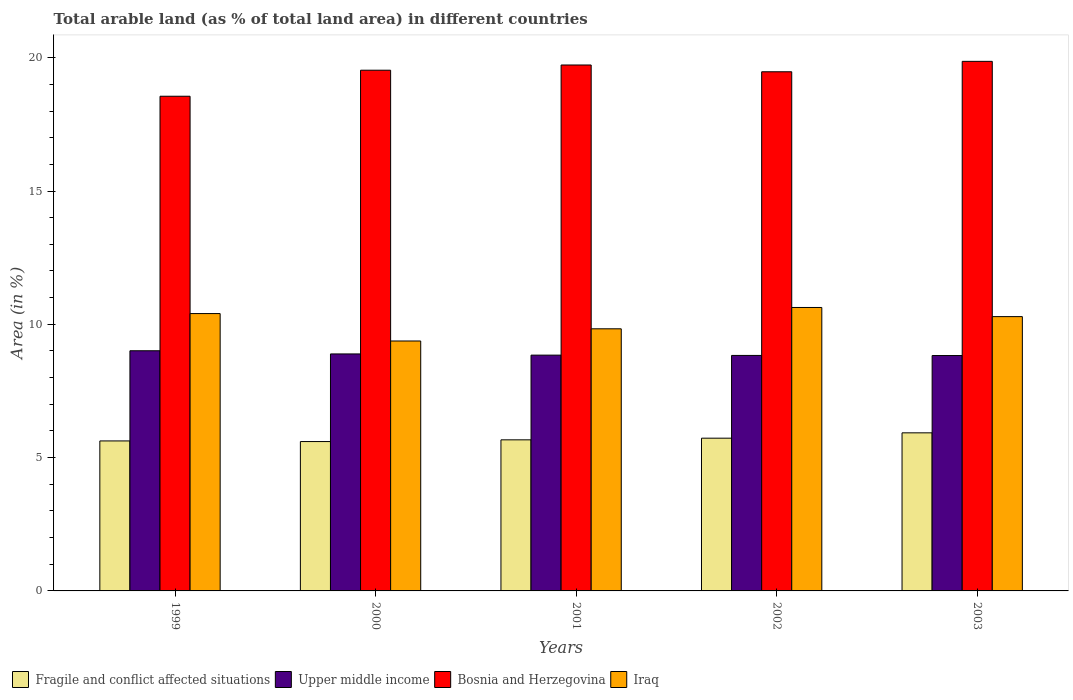In how many cases, is the number of bars for a given year not equal to the number of legend labels?
Your response must be concise. 0. What is the percentage of arable land in Upper middle income in 2002?
Provide a short and direct response. 8.83. Across all years, what is the maximum percentage of arable land in Bosnia and Herzegovina?
Your answer should be very brief. 19.86. Across all years, what is the minimum percentage of arable land in Bosnia and Herzegovina?
Keep it short and to the point. 18.55. What is the total percentage of arable land in Iraq in the graph?
Your answer should be very brief. 50.53. What is the difference between the percentage of arable land in Upper middle income in 2000 and that in 2001?
Offer a very short reply. 0.05. What is the difference between the percentage of arable land in Upper middle income in 2003 and the percentage of arable land in Iraq in 2001?
Your response must be concise. -1. What is the average percentage of arable land in Bosnia and Herzegovina per year?
Give a very brief answer. 19.43. In the year 2003, what is the difference between the percentage of arable land in Upper middle income and percentage of arable land in Bosnia and Herzegovina?
Your answer should be very brief. -11.03. What is the ratio of the percentage of arable land in Upper middle income in 2000 to that in 2002?
Provide a succinct answer. 1.01. Is the percentage of arable land in Iraq in 1999 less than that in 2002?
Your response must be concise. Yes. Is the difference between the percentage of arable land in Upper middle income in 2000 and 2001 greater than the difference between the percentage of arable land in Bosnia and Herzegovina in 2000 and 2001?
Provide a succinct answer. Yes. What is the difference between the highest and the second highest percentage of arable land in Iraq?
Provide a short and direct response. 0.23. What is the difference between the highest and the lowest percentage of arable land in Bosnia and Herzegovina?
Provide a succinct answer. 1.31. Is the sum of the percentage of arable land in Upper middle income in 1999 and 2001 greater than the maximum percentage of arable land in Bosnia and Herzegovina across all years?
Offer a terse response. No. What does the 4th bar from the left in 2003 represents?
Ensure brevity in your answer.  Iraq. What does the 4th bar from the right in 2001 represents?
Offer a terse response. Fragile and conflict affected situations. Is it the case that in every year, the sum of the percentage of arable land in Bosnia and Herzegovina and percentage of arable land in Iraq is greater than the percentage of arable land in Upper middle income?
Keep it short and to the point. Yes. How many bars are there?
Give a very brief answer. 20. How many years are there in the graph?
Your answer should be very brief. 5. Are the values on the major ticks of Y-axis written in scientific E-notation?
Offer a very short reply. No. Does the graph contain any zero values?
Make the answer very short. No. Does the graph contain grids?
Make the answer very short. No. Where does the legend appear in the graph?
Your answer should be very brief. Bottom left. How are the legend labels stacked?
Your response must be concise. Horizontal. What is the title of the graph?
Ensure brevity in your answer.  Total arable land (as % of total land area) in different countries. What is the label or title of the Y-axis?
Provide a short and direct response. Area (in %). What is the Area (in %) in Fragile and conflict affected situations in 1999?
Keep it short and to the point. 5.63. What is the Area (in %) in Upper middle income in 1999?
Give a very brief answer. 9.01. What is the Area (in %) of Bosnia and Herzegovina in 1999?
Keep it short and to the point. 18.55. What is the Area (in %) in Iraq in 1999?
Provide a succinct answer. 10.4. What is the Area (in %) of Fragile and conflict affected situations in 2000?
Provide a short and direct response. 5.6. What is the Area (in %) in Upper middle income in 2000?
Offer a terse response. 8.89. What is the Area (in %) of Bosnia and Herzegovina in 2000?
Provide a succinct answer. 19.53. What is the Area (in %) of Iraq in 2000?
Keep it short and to the point. 9.37. What is the Area (in %) in Fragile and conflict affected situations in 2001?
Your response must be concise. 5.67. What is the Area (in %) of Upper middle income in 2001?
Offer a very short reply. 8.84. What is the Area (in %) of Bosnia and Herzegovina in 2001?
Your response must be concise. 19.73. What is the Area (in %) of Iraq in 2001?
Provide a short and direct response. 9.83. What is the Area (in %) of Fragile and conflict affected situations in 2002?
Offer a terse response. 5.73. What is the Area (in %) of Upper middle income in 2002?
Make the answer very short. 8.83. What is the Area (in %) of Bosnia and Herzegovina in 2002?
Provide a short and direct response. 19.47. What is the Area (in %) of Iraq in 2002?
Keep it short and to the point. 10.63. What is the Area (in %) of Fragile and conflict affected situations in 2003?
Provide a short and direct response. 5.93. What is the Area (in %) in Upper middle income in 2003?
Keep it short and to the point. 8.83. What is the Area (in %) in Bosnia and Herzegovina in 2003?
Keep it short and to the point. 19.86. What is the Area (in %) in Iraq in 2003?
Provide a short and direct response. 10.29. Across all years, what is the maximum Area (in %) of Fragile and conflict affected situations?
Your answer should be very brief. 5.93. Across all years, what is the maximum Area (in %) in Upper middle income?
Ensure brevity in your answer.  9.01. Across all years, what is the maximum Area (in %) in Bosnia and Herzegovina?
Your answer should be very brief. 19.86. Across all years, what is the maximum Area (in %) of Iraq?
Your answer should be compact. 10.63. Across all years, what is the minimum Area (in %) of Fragile and conflict affected situations?
Provide a succinct answer. 5.6. Across all years, what is the minimum Area (in %) of Upper middle income?
Offer a very short reply. 8.83. Across all years, what is the minimum Area (in %) of Bosnia and Herzegovina?
Give a very brief answer. 18.55. Across all years, what is the minimum Area (in %) in Iraq?
Keep it short and to the point. 9.37. What is the total Area (in %) of Fragile and conflict affected situations in the graph?
Keep it short and to the point. 28.55. What is the total Area (in %) of Upper middle income in the graph?
Give a very brief answer. 44.4. What is the total Area (in %) in Bosnia and Herzegovina in the graph?
Offer a terse response. 97.15. What is the total Area (in %) in Iraq in the graph?
Your response must be concise. 50.53. What is the difference between the Area (in %) of Fragile and conflict affected situations in 1999 and that in 2000?
Your answer should be compact. 0.02. What is the difference between the Area (in %) in Upper middle income in 1999 and that in 2000?
Make the answer very short. 0.12. What is the difference between the Area (in %) in Bosnia and Herzegovina in 1999 and that in 2000?
Your answer should be compact. -0.98. What is the difference between the Area (in %) in Iraq in 1999 and that in 2000?
Provide a short and direct response. 1.03. What is the difference between the Area (in %) in Fragile and conflict affected situations in 1999 and that in 2001?
Your response must be concise. -0.04. What is the difference between the Area (in %) of Upper middle income in 1999 and that in 2001?
Keep it short and to the point. 0.16. What is the difference between the Area (in %) of Bosnia and Herzegovina in 1999 and that in 2001?
Make the answer very short. -1.17. What is the difference between the Area (in %) in Iraq in 1999 and that in 2001?
Provide a succinct answer. 0.57. What is the difference between the Area (in %) of Fragile and conflict affected situations in 1999 and that in 2002?
Your response must be concise. -0.1. What is the difference between the Area (in %) in Upper middle income in 1999 and that in 2002?
Offer a very short reply. 0.18. What is the difference between the Area (in %) in Bosnia and Herzegovina in 1999 and that in 2002?
Give a very brief answer. -0.92. What is the difference between the Area (in %) of Iraq in 1999 and that in 2002?
Offer a very short reply. -0.23. What is the difference between the Area (in %) of Fragile and conflict affected situations in 1999 and that in 2003?
Offer a very short reply. -0.3. What is the difference between the Area (in %) of Upper middle income in 1999 and that in 2003?
Provide a succinct answer. 0.18. What is the difference between the Area (in %) in Bosnia and Herzegovina in 1999 and that in 2003?
Provide a short and direct response. -1.31. What is the difference between the Area (in %) in Iraq in 1999 and that in 2003?
Your answer should be very brief. 0.11. What is the difference between the Area (in %) of Fragile and conflict affected situations in 2000 and that in 2001?
Your response must be concise. -0.06. What is the difference between the Area (in %) of Upper middle income in 2000 and that in 2001?
Ensure brevity in your answer.  0.04. What is the difference between the Area (in %) of Bosnia and Herzegovina in 2000 and that in 2001?
Give a very brief answer. -0.2. What is the difference between the Area (in %) in Iraq in 2000 and that in 2001?
Your answer should be compact. -0.46. What is the difference between the Area (in %) of Fragile and conflict affected situations in 2000 and that in 2002?
Ensure brevity in your answer.  -0.13. What is the difference between the Area (in %) in Upper middle income in 2000 and that in 2002?
Offer a terse response. 0.06. What is the difference between the Area (in %) in Bosnia and Herzegovina in 2000 and that in 2002?
Your answer should be compact. 0.06. What is the difference between the Area (in %) of Iraq in 2000 and that in 2002?
Offer a terse response. -1.26. What is the difference between the Area (in %) in Fragile and conflict affected situations in 2000 and that in 2003?
Make the answer very short. -0.33. What is the difference between the Area (in %) of Bosnia and Herzegovina in 2000 and that in 2003?
Your answer should be compact. -0.33. What is the difference between the Area (in %) in Iraq in 2000 and that in 2003?
Keep it short and to the point. -0.91. What is the difference between the Area (in %) in Fragile and conflict affected situations in 2001 and that in 2002?
Your response must be concise. -0.06. What is the difference between the Area (in %) of Upper middle income in 2001 and that in 2002?
Your answer should be very brief. 0.01. What is the difference between the Area (in %) in Bosnia and Herzegovina in 2001 and that in 2002?
Make the answer very short. 0.25. What is the difference between the Area (in %) in Iraq in 2001 and that in 2002?
Provide a short and direct response. -0.8. What is the difference between the Area (in %) in Fragile and conflict affected situations in 2001 and that in 2003?
Offer a very short reply. -0.26. What is the difference between the Area (in %) in Upper middle income in 2001 and that in 2003?
Offer a terse response. 0.01. What is the difference between the Area (in %) in Bosnia and Herzegovina in 2001 and that in 2003?
Provide a short and direct response. -0.14. What is the difference between the Area (in %) of Iraq in 2001 and that in 2003?
Provide a short and direct response. -0.46. What is the difference between the Area (in %) of Fragile and conflict affected situations in 2002 and that in 2003?
Offer a terse response. -0.2. What is the difference between the Area (in %) of Upper middle income in 2002 and that in 2003?
Provide a short and direct response. 0. What is the difference between the Area (in %) in Bosnia and Herzegovina in 2002 and that in 2003?
Ensure brevity in your answer.  -0.39. What is the difference between the Area (in %) of Iraq in 2002 and that in 2003?
Your answer should be very brief. 0.34. What is the difference between the Area (in %) of Fragile and conflict affected situations in 1999 and the Area (in %) of Upper middle income in 2000?
Offer a terse response. -3.26. What is the difference between the Area (in %) in Fragile and conflict affected situations in 1999 and the Area (in %) in Bosnia and Herzegovina in 2000?
Provide a succinct answer. -13.91. What is the difference between the Area (in %) of Fragile and conflict affected situations in 1999 and the Area (in %) of Iraq in 2000?
Make the answer very short. -3.75. What is the difference between the Area (in %) in Upper middle income in 1999 and the Area (in %) in Bosnia and Herzegovina in 2000?
Give a very brief answer. -10.52. What is the difference between the Area (in %) in Upper middle income in 1999 and the Area (in %) in Iraq in 2000?
Offer a very short reply. -0.37. What is the difference between the Area (in %) of Bosnia and Herzegovina in 1999 and the Area (in %) of Iraq in 2000?
Your answer should be very brief. 9.18. What is the difference between the Area (in %) of Fragile and conflict affected situations in 1999 and the Area (in %) of Upper middle income in 2001?
Your answer should be compact. -3.22. What is the difference between the Area (in %) of Fragile and conflict affected situations in 1999 and the Area (in %) of Bosnia and Herzegovina in 2001?
Your response must be concise. -14.1. What is the difference between the Area (in %) of Fragile and conflict affected situations in 1999 and the Area (in %) of Iraq in 2001?
Provide a succinct answer. -4.21. What is the difference between the Area (in %) of Upper middle income in 1999 and the Area (in %) of Bosnia and Herzegovina in 2001?
Ensure brevity in your answer.  -10.72. What is the difference between the Area (in %) in Upper middle income in 1999 and the Area (in %) in Iraq in 2001?
Make the answer very short. -0.82. What is the difference between the Area (in %) of Bosnia and Herzegovina in 1999 and the Area (in %) of Iraq in 2001?
Your answer should be very brief. 8.72. What is the difference between the Area (in %) in Fragile and conflict affected situations in 1999 and the Area (in %) in Upper middle income in 2002?
Give a very brief answer. -3.21. What is the difference between the Area (in %) in Fragile and conflict affected situations in 1999 and the Area (in %) in Bosnia and Herzegovina in 2002?
Keep it short and to the point. -13.85. What is the difference between the Area (in %) in Fragile and conflict affected situations in 1999 and the Area (in %) in Iraq in 2002?
Offer a very short reply. -5.01. What is the difference between the Area (in %) in Upper middle income in 1999 and the Area (in %) in Bosnia and Herzegovina in 2002?
Provide a short and direct response. -10.46. What is the difference between the Area (in %) in Upper middle income in 1999 and the Area (in %) in Iraq in 2002?
Your answer should be very brief. -1.62. What is the difference between the Area (in %) of Bosnia and Herzegovina in 1999 and the Area (in %) of Iraq in 2002?
Make the answer very short. 7.92. What is the difference between the Area (in %) of Fragile and conflict affected situations in 1999 and the Area (in %) of Upper middle income in 2003?
Ensure brevity in your answer.  -3.2. What is the difference between the Area (in %) of Fragile and conflict affected situations in 1999 and the Area (in %) of Bosnia and Herzegovina in 2003?
Provide a succinct answer. -14.24. What is the difference between the Area (in %) in Fragile and conflict affected situations in 1999 and the Area (in %) in Iraq in 2003?
Make the answer very short. -4.66. What is the difference between the Area (in %) of Upper middle income in 1999 and the Area (in %) of Bosnia and Herzegovina in 2003?
Your answer should be very brief. -10.85. What is the difference between the Area (in %) in Upper middle income in 1999 and the Area (in %) in Iraq in 2003?
Your answer should be compact. -1.28. What is the difference between the Area (in %) in Bosnia and Herzegovina in 1999 and the Area (in %) in Iraq in 2003?
Your answer should be very brief. 8.27. What is the difference between the Area (in %) in Fragile and conflict affected situations in 2000 and the Area (in %) in Upper middle income in 2001?
Your answer should be very brief. -3.24. What is the difference between the Area (in %) of Fragile and conflict affected situations in 2000 and the Area (in %) of Bosnia and Herzegovina in 2001?
Your answer should be compact. -14.12. What is the difference between the Area (in %) in Fragile and conflict affected situations in 2000 and the Area (in %) in Iraq in 2001?
Give a very brief answer. -4.23. What is the difference between the Area (in %) in Upper middle income in 2000 and the Area (in %) in Bosnia and Herzegovina in 2001?
Provide a short and direct response. -10.84. What is the difference between the Area (in %) in Upper middle income in 2000 and the Area (in %) in Iraq in 2001?
Keep it short and to the point. -0.94. What is the difference between the Area (in %) of Bosnia and Herzegovina in 2000 and the Area (in %) of Iraq in 2001?
Your answer should be compact. 9.7. What is the difference between the Area (in %) in Fragile and conflict affected situations in 2000 and the Area (in %) in Upper middle income in 2002?
Ensure brevity in your answer.  -3.23. What is the difference between the Area (in %) of Fragile and conflict affected situations in 2000 and the Area (in %) of Bosnia and Herzegovina in 2002?
Your answer should be very brief. -13.87. What is the difference between the Area (in %) in Fragile and conflict affected situations in 2000 and the Area (in %) in Iraq in 2002?
Give a very brief answer. -5.03. What is the difference between the Area (in %) of Upper middle income in 2000 and the Area (in %) of Bosnia and Herzegovina in 2002?
Keep it short and to the point. -10.58. What is the difference between the Area (in %) of Upper middle income in 2000 and the Area (in %) of Iraq in 2002?
Offer a very short reply. -1.74. What is the difference between the Area (in %) of Bosnia and Herzegovina in 2000 and the Area (in %) of Iraq in 2002?
Provide a short and direct response. 8.9. What is the difference between the Area (in %) in Fragile and conflict affected situations in 2000 and the Area (in %) in Upper middle income in 2003?
Your answer should be compact. -3.23. What is the difference between the Area (in %) of Fragile and conflict affected situations in 2000 and the Area (in %) of Bosnia and Herzegovina in 2003?
Offer a very short reply. -14.26. What is the difference between the Area (in %) in Fragile and conflict affected situations in 2000 and the Area (in %) in Iraq in 2003?
Your response must be concise. -4.69. What is the difference between the Area (in %) of Upper middle income in 2000 and the Area (in %) of Bosnia and Herzegovina in 2003?
Make the answer very short. -10.97. What is the difference between the Area (in %) in Upper middle income in 2000 and the Area (in %) in Iraq in 2003?
Offer a terse response. -1.4. What is the difference between the Area (in %) of Bosnia and Herzegovina in 2000 and the Area (in %) of Iraq in 2003?
Offer a terse response. 9.24. What is the difference between the Area (in %) of Fragile and conflict affected situations in 2001 and the Area (in %) of Upper middle income in 2002?
Give a very brief answer. -3.17. What is the difference between the Area (in %) of Fragile and conflict affected situations in 2001 and the Area (in %) of Bosnia and Herzegovina in 2002?
Give a very brief answer. -13.81. What is the difference between the Area (in %) in Fragile and conflict affected situations in 2001 and the Area (in %) in Iraq in 2002?
Give a very brief answer. -4.96. What is the difference between the Area (in %) of Upper middle income in 2001 and the Area (in %) of Bosnia and Herzegovina in 2002?
Your answer should be very brief. -10.63. What is the difference between the Area (in %) of Upper middle income in 2001 and the Area (in %) of Iraq in 2002?
Give a very brief answer. -1.79. What is the difference between the Area (in %) in Bosnia and Herzegovina in 2001 and the Area (in %) in Iraq in 2002?
Make the answer very short. 9.09. What is the difference between the Area (in %) of Fragile and conflict affected situations in 2001 and the Area (in %) of Upper middle income in 2003?
Provide a short and direct response. -3.16. What is the difference between the Area (in %) in Fragile and conflict affected situations in 2001 and the Area (in %) in Bosnia and Herzegovina in 2003?
Offer a terse response. -14.2. What is the difference between the Area (in %) of Fragile and conflict affected situations in 2001 and the Area (in %) of Iraq in 2003?
Give a very brief answer. -4.62. What is the difference between the Area (in %) in Upper middle income in 2001 and the Area (in %) in Bosnia and Herzegovina in 2003?
Provide a succinct answer. -11.02. What is the difference between the Area (in %) in Upper middle income in 2001 and the Area (in %) in Iraq in 2003?
Provide a succinct answer. -1.44. What is the difference between the Area (in %) of Bosnia and Herzegovina in 2001 and the Area (in %) of Iraq in 2003?
Your answer should be compact. 9.44. What is the difference between the Area (in %) in Fragile and conflict affected situations in 2002 and the Area (in %) in Upper middle income in 2003?
Ensure brevity in your answer.  -3.1. What is the difference between the Area (in %) in Fragile and conflict affected situations in 2002 and the Area (in %) in Bosnia and Herzegovina in 2003?
Your answer should be compact. -14.13. What is the difference between the Area (in %) in Fragile and conflict affected situations in 2002 and the Area (in %) in Iraq in 2003?
Your response must be concise. -4.56. What is the difference between the Area (in %) in Upper middle income in 2002 and the Area (in %) in Bosnia and Herzegovina in 2003?
Your answer should be very brief. -11.03. What is the difference between the Area (in %) of Upper middle income in 2002 and the Area (in %) of Iraq in 2003?
Ensure brevity in your answer.  -1.46. What is the difference between the Area (in %) in Bosnia and Herzegovina in 2002 and the Area (in %) in Iraq in 2003?
Give a very brief answer. 9.18. What is the average Area (in %) in Fragile and conflict affected situations per year?
Keep it short and to the point. 5.71. What is the average Area (in %) in Upper middle income per year?
Keep it short and to the point. 8.88. What is the average Area (in %) of Bosnia and Herzegovina per year?
Give a very brief answer. 19.43. What is the average Area (in %) of Iraq per year?
Provide a short and direct response. 10.11. In the year 1999, what is the difference between the Area (in %) of Fragile and conflict affected situations and Area (in %) of Upper middle income?
Give a very brief answer. -3.38. In the year 1999, what is the difference between the Area (in %) of Fragile and conflict affected situations and Area (in %) of Bosnia and Herzegovina?
Ensure brevity in your answer.  -12.93. In the year 1999, what is the difference between the Area (in %) in Fragile and conflict affected situations and Area (in %) in Iraq?
Offer a very short reply. -4.78. In the year 1999, what is the difference between the Area (in %) of Upper middle income and Area (in %) of Bosnia and Herzegovina?
Keep it short and to the point. -9.55. In the year 1999, what is the difference between the Area (in %) of Upper middle income and Area (in %) of Iraq?
Provide a short and direct response. -1.39. In the year 1999, what is the difference between the Area (in %) in Bosnia and Herzegovina and Area (in %) in Iraq?
Provide a succinct answer. 8.15. In the year 2000, what is the difference between the Area (in %) in Fragile and conflict affected situations and Area (in %) in Upper middle income?
Your answer should be compact. -3.29. In the year 2000, what is the difference between the Area (in %) of Fragile and conflict affected situations and Area (in %) of Bosnia and Herzegovina?
Your answer should be compact. -13.93. In the year 2000, what is the difference between the Area (in %) in Fragile and conflict affected situations and Area (in %) in Iraq?
Provide a succinct answer. -3.77. In the year 2000, what is the difference between the Area (in %) in Upper middle income and Area (in %) in Bosnia and Herzegovina?
Offer a terse response. -10.64. In the year 2000, what is the difference between the Area (in %) of Upper middle income and Area (in %) of Iraq?
Your answer should be compact. -0.49. In the year 2000, what is the difference between the Area (in %) of Bosnia and Herzegovina and Area (in %) of Iraq?
Your response must be concise. 10.16. In the year 2001, what is the difference between the Area (in %) in Fragile and conflict affected situations and Area (in %) in Upper middle income?
Keep it short and to the point. -3.18. In the year 2001, what is the difference between the Area (in %) in Fragile and conflict affected situations and Area (in %) in Bosnia and Herzegovina?
Provide a short and direct response. -14.06. In the year 2001, what is the difference between the Area (in %) of Fragile and conflict affected situations and Area (in %) of Iraq?
Provide a succinct answer. -4.16. In the year 2001, what is the difference between the Area (in %) in Upper middle income and Area (in %) in Bosnia and Herzegovina?
Offer a terse response. -10.88. In the year 2001, what is the difference between the Area (in %) of Upper middle income and Area (in %) of Iraq?
Provide a succinct answer. -0.99. In the year 2001, what is the difference between the Area (in %) in Bosnia and Herzegovina and Area (in %) in Iraq?
Provide a short and direct response. 9.9. In the year 2002, what is the difference between the Area (in %) in Fragile and conflict affected situations and Area (in %) in Upper middle income?
Make the answer very short. -3.1. In the year 2002, what is the difference between the Area (in %) of Fragile and conflict affected situations and Area (in %) of Bosnia and Herzegovina?
Offer a very short reply. -13.74. In the year 2002, what is the difference between the Area (in %) of Fragile and conflict affected situations and Area (in %) of Iraq?
Your answer should be very brief. -4.9. In the year 2002, what is the difference between the Area (in %) of Upper middle income and Area (in %) of Bosnia and Herzegovina?
Offer a very short reply. -10.64. In the year 2002, what is the difference between the Area (in %) of Upper middle income and Area (in %) of Iraq?
Ensure brevity in your answer.  -1.8. In the year 2002, what is the difference between the Area (in %) of Bosnia and Herzegovina and Area (in %) of Iraq?
Provide a short and direct response. 8.84. In the year 2003, what is the difference between the Area (in %) of Fragile and conflict affected situations and Area (in %) of Upper middle income?
Provide a short and direct response. -2.9. In the year 2003, what is the difference between the Area (in %) of Fragile and conflict affected situations and Area (in %) of Bosnia and Herzegovina?
Make the answer very short. -13.93. In the year 2003, what is the difference between the Area (in %) in Fragile and conflict affected situations and Area (in %) in Iraq?
Keep it short and to the point. -4.36. In the year 2003, what is the difference between the Area (in %) in Upper middle income and Area (in %) in Bosnia and Herzegovina?
Offer a terse response. -11.03. In the year 2003, what is the difference between the Area (in %) in Upper middle income and Area (in %) in Iraq?
Give a very brief answer. -1.46. In the year 2003, what is the difference between the Area (in %) of Bosnia and Herzegovina and Area (in %) of Iraq?
Keep it short and to the point. 9.57. What is the ratio of the Area (in %) in Upper middle income in 1999 to that in 2000?
Your answer should be very brief. 1.01. What is the ratio of the Area (in %) of Iraq in 1999 to that in 2000?
Offer a terse response. 1.11. What is the ratio of the Area (in %) in Upper middle income in 1999 to that in 2001?
Your answer should be very brief. 1.02. What is the ratio of the Area (in %) in Bosnia and Herzegovina in 1999 to that in 2001?
Give a very brief answer. 0.94. What is the ratio of the Area (in %) of Iraq in 1999 to that in 2001?
Offer a very short reply. 1.06. What is the ratio of the Area (in %) in Fragile and conflict affected situations in 1999 to that in 2002?
Offer a terse response. 0.98. What is the ratio of the Area (in %) of Upper middle income in 1999 to that in 2002?
Ensure brevity in your answer.  1.02. What is the ratio of the Area (in %) in Bosnia and Herzegovina in 1999 to that in 2002?
Ensure brevity in your answer.  0.95. What is the ratio of the Area (in %) of Iraq in 1999 to that in 2002?
Offer a very short reply. 0.98. What is the ratio of the Area (in %) of Fragile and conflict affected situations in 1999 to that in 2003?
Your answer should be very brief. 0.95. What is the ratio of the Area (in %) in Upper middle income in 1999 to that in 2003?
Provide a succinct answer. 1.02. What is the ratio of the Area (in %) of Bosnia and Herzegovina in 1999 to that in 2003?
Your response must be concise. 0.93. What is the ratio of the Area (in %) in Iraq in 1999 to that in 2003?
Ensure brevity in your answer.  1.01. What is the ratio of the Area (in %) in Fragile and conflict affected situations in 2000 to that in 2001?
Provide a short and direct response. 0.99. What is the ratio of the Area (in %) of Bosnia and Herzegovina in 2000 to that in 2001?
Provide a short and direct response. 0.99. What is the ratio of the Area (in %) of Iraq in 2000 to that in 2001?
Give a very brief answer. 0.95. What is the ratio of the Area (in %) in Fragile and conflict affected situations in 2000 to that in 2002?
Give a very brief answer. 0.98. What is the ratio of the Area (in %) of Upper middle income in 2000 to that in 2002?
Offer a very short reply. 1.01. What is the ratio of the Area (in %) in Bosnia and Herzegovina in 2000 to that in 2002?
Provide a short and direct response. 1. What is the ratio of the Area (in %) in Iraq in 2000 to that in 2002?
Your answer should be compact. 0.88. What is the ratio of the Area (in %) of Fragile and conflict affected situations in 2000 to that in 2003?
Your answer should be compact. 0.94. What is the ratio of the Area (in %) of Upper middle income in 2000 to that in 2003?
Your response must be concise. 1.01. What is the ratio of the Area (in %) in Bosnia and Herzegovina in 2000 to that in 2003?
Give a very brief answer. 0.98. What is the ratio of the Area (in %) in Iraq in 2000 to that in 2003?
Your answer should be compact. 0.91. What is the ratio of the Area (in %) in Fragile and conflict affected situations in 2001 to that in 2002?
Offer a terse response. 0.99. What is the ratio of the Area (in %) in Bosnia and Herzegovina in 2001 to that in 2002?
Provide a short and direct response. 1.01. What is the ratio of the Area (in %) of Iraq in 2001 to that in 2002?
Offer a terse response. 0.92. What is the ratio of the Area (in %) in Fragile and conflict affected situations in 2001 to that in 2003?
Ensure brevity in your answer.  0.96. What is the ratio of the Area (in %) in Iraq in 2001 to that in 2003?
Offer a very short reply. 0.96. What is the ratio of the Area (in %) of Fragile and conflict affected situations in 2002 to that in 2003?
Your answer should be very brief. 0.97. What is the ratio of the Area (in %) in Upper middle income in 2002 to that in 2003?
Keep it short and to the point. 1. What is the ratio of the Area (in %) of Bosnia and Herzegovina in 2002 to that in 2003?
Offer a terse response. 0.98. What is the difference between the highest and the second highest Area (in %) of Fragile and conflict affected situations?
Offer a very short reply. 0.2. What is the difference between the highest and the second highest Area (in %) in Upper middle income?
Provide a short and direct response. 0.12. What is the difference between the highest and the second highest Area (in %) in Bosnia and Herzegovina?
Offer a very short reply. 0.14. What is the difference between the highest and the second highest Area (in %) of Iraq?
Your response must be concise. 0.23. What is the difference between the highest and the lowest Area (in %) of Fragile and conflict affected situations?
Keep it short and to the point. 0.33. What is the difference between the highest and the lowest Area (in %) of Upper middle income?
Make the answer very short. 0.18. What is the difference between the highest and the lowest Area (in %) of Bosnia and Herzegovina?
Your answer should be very brief. 1.31. What is the difference between the highest and the lowest Area (in %) in Iraq?
Make the answer very short. 1.26. 